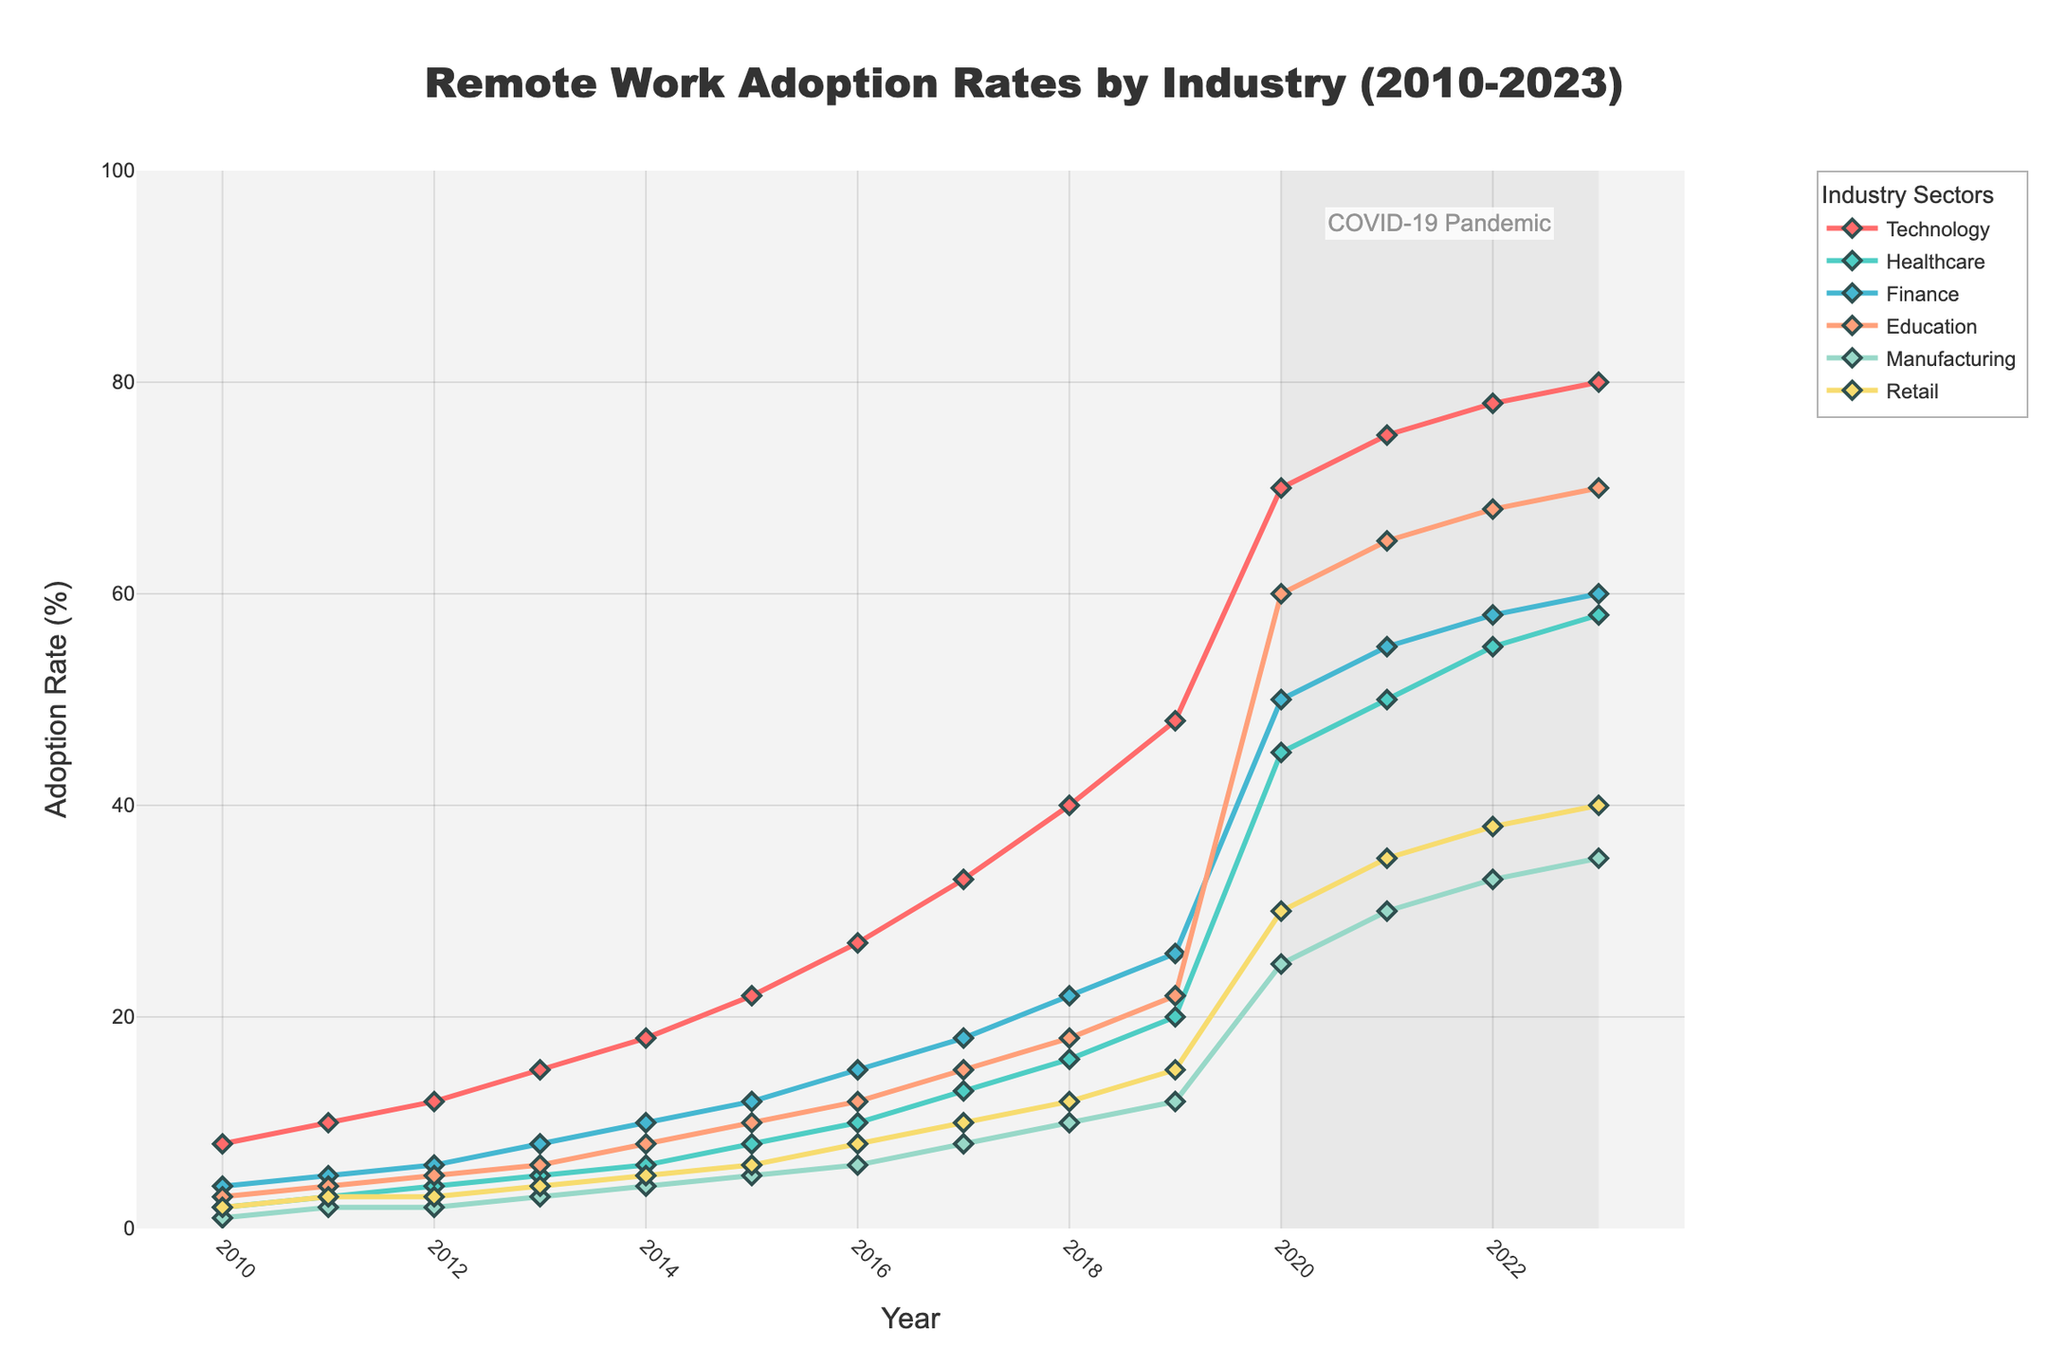What is the adoption rate of remote work in the Technology sector in 2015? Look at the curve corresponding to the Technology sector and find the point where the year is 2015. The value at this point represents the adoption rate of remote work in the Technology sector for that year.
Answer: 22% What is the difference in remote work adoption rates for the Healthcare sector between 2023 and 2010? Find the adoption rate for Healthcare in both 2023 and 2010 along their respective lines. Subtract the value of 2010 from the value of 2023 to get the difference.
Answer: 56% Which sector had the highest adoption rate of remote work in 2022? Look at the points corresponding to 2022 across all sectors on the graph. Compare the heights of these points and identify the sector with the highest value.
Answer: Technology Between 2019 and 2020, which sector shows the largest increase in remote work adoption rates? Calculate the increase in adoption rates for each sector between 2019 and 2020 by subtracting the 2019 value from the 2020 value. Identify the sector with the largest difference.
Answer: Technology What is the average adoption rate of remote work for the Finance sector from 2010 to 2013? Sum the adoption rates for Finance from 2010 to 2013 and then divide by the number of years to find the average. (4 + 5 + 6 + 8) / 4 = 5.75
Answer: 5.75% In which year did the Education sector see a rapid increase in remote work adoption rates, and by how much? Examine the growth of the Education sector line and identify years with notable jumps. Find the year and calculate the difference from the previous year.
Answer: 2020, 38% Compare the remote work adoption rate trends for Manufacturing and Retail sectors between 2016 and 2021. Which sector showed greater consistency? Look at the lines representing Manufacturing and Retail from 2016 to 2021 and observe their trajectories. Identify which line's changes are smoother and less volatile.
Answer: Retail How much did the adoption rate for remote work in the Healthcare sector change from 2019 to 2021? Find the adoption rates for Healthcare in 2019 and 2021. Subtract the value for 2019 from the value for 2021 to find the change.
Answer: 30% What is the total increase in the remote work adoption rate for the Technology sector from 2010 to 2023? Subtract the adoption rate of remote work in the Technology sector in 2010 from its adoption rate in 2023 to get the total increase.
Answer: 72% During the COVID-19 pandemic (2020-2023), which sector showed the least change in remote work adoption rates? Look at the gradients of all sector lines during the period 2020-2023. Identify the sector with the smallest change in rate (least steep line).
Answer: Finance 